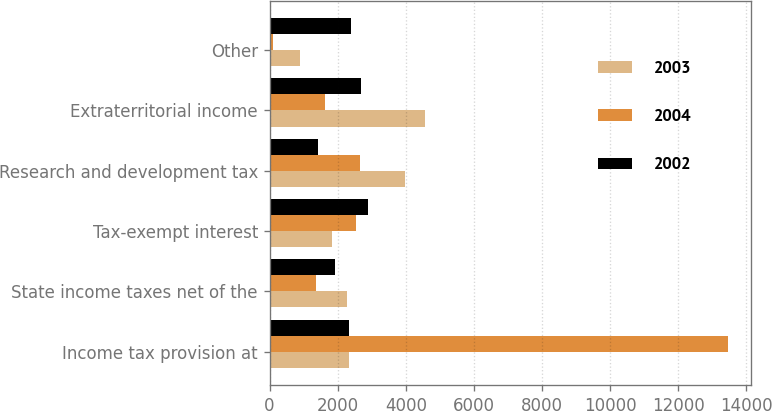Convert chart to OTSL. <chart><loc_0><loc_0><loc_500><loc_500><stacked_bar_chart><ecel><fcel>Income tax provision at<fcel>State income taxes net of the<fcel>Tax-exempt interest<fcel>Research and development tax<fcel>Extraterritorial income<fcel>Other<nl><fcel>2003<fcel>2328<fcel>2279<fcel>1846<fcel>3968<fcel>4575<fcel>884<nl><fcel>2004<fcel>13463<fcel>1361<fcel>2551<fcel>2668<fcel>1632<fcel>112<nl><fcel>2002<fcel>2328<fcel>1907<fcel>2882<fcel>1433<fcel>2690<fcel>2377<nl></chart> 